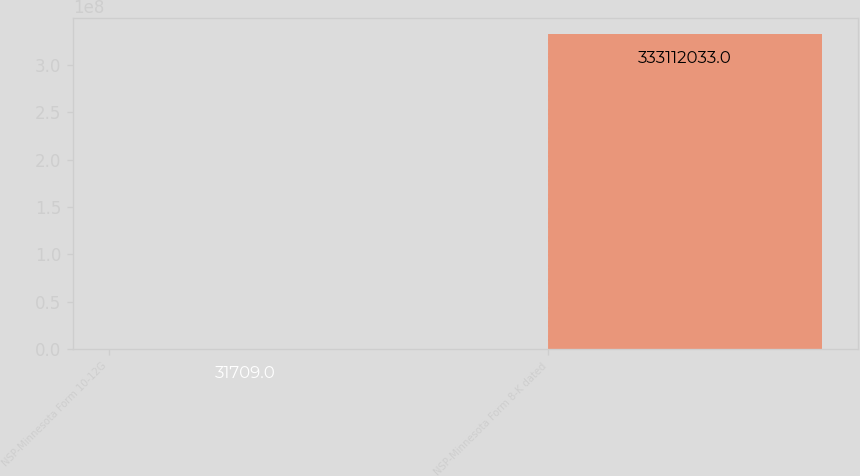Convert chart. <chart><loc_0><loc_0><loc_500><loc_500><bar_chart><fcel>NSP-Minnesota Form 10-12G<fcel>NSP-Minnesota Form 8-K dated<nl><fcel>31709<fcel>3.33112e+08<nl></chart> 